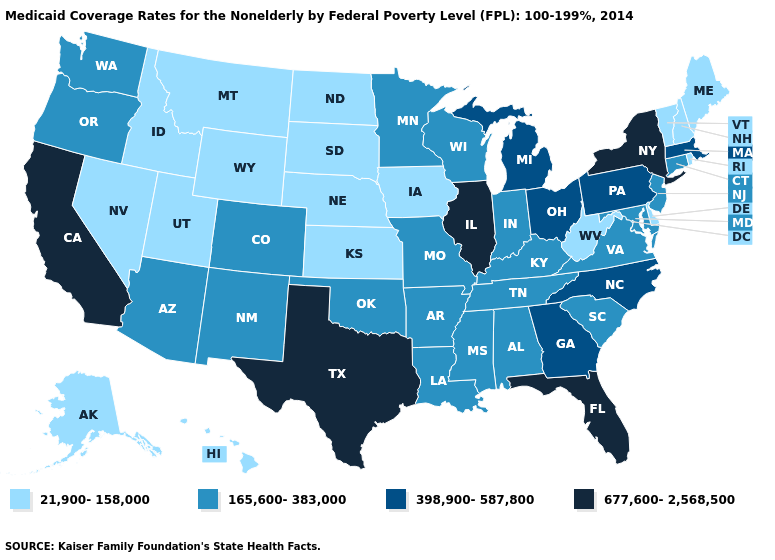Name the states that have a value in the range 165,600-383,000?
Write a very short answer. Alabama, Arizona, Arkansas, Colorado, Connecticut, Indiana, Kentucky, Louisiana, Maryland, Minnesota, Mississippi, Missouri, New Jersey, New Mexico, Oklahoma, Oregon, South Carolina, Tennessee, Virginia, Washington, Wisconsin. Among the states that border Michigan , does Indiana have the lowest value?
Give a very brief answer. Yes. Is the legend a continuous bar?
Quick response, please. No. What is the highest value in states that border Massachusetts?
Answer briefly. 677,600-2,568,500. What is the value of West Virginia?
Be succinct. 21,900-158,000. Name the states that have a value in the range 677,600-2,568,500?
Answer briefly. California, Florida, Illinois, New York, Texas. Name the states that have a value in the range 398,900-587,800?
Keep it brief. Georgia, Massachusetts, Michigan, North Carolina, Ohio, Pennsylvania. Among the states that border Arkansas , does Texas have the highest value?
Short answer required. Yes. What is the value of Colorado?
Concise answer only. 165,600-383,000. Which states have the highest value in the USA?
Write a very short answer. California, Florida, Illinois, New York, Texas. What is the highest value in the USA?
Quick response, please. 677,600-2,568,500. Is the legend a continuous bar?
Answer briefly. No. What is the highest value in the USA?
Concise answer only. 677,600-2,568,500. What is the value of Pennsylvania?
Short answer required. 398,900-587,800. What is the highest value in the MidWest ?
Give a very brief answer. 677,600-2,568,500. 